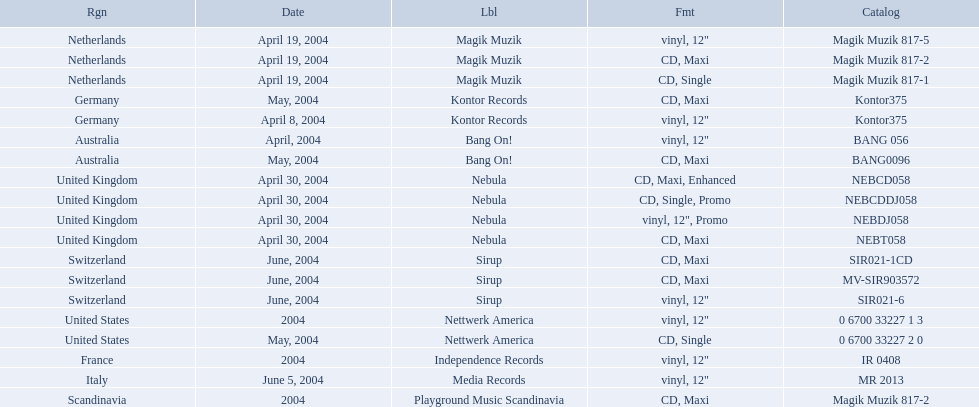What label was used by the netherlands in love comes again? Magik Muzik. What label was used in germany? Kontor Records. What label was used in france? Independence Records. What are the labels for love comes again? Magik Muzik, Magik Muzik, Magik Muzik, Kontor Records, Kontor Records, Bang On!, Bang On!, Nebula, Nebula, Nebula, Nebula, Sirup, Sirup, Sirup, Nettwerk America, Nettwerk America, Independence Records, Media Records, Playground Music Scandinavia. What label has been used by the region of france? Independence Records. 